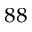<formula> <loc_0><loc_0><loc_500><loc_500>^ { 8 8 }</formula> 